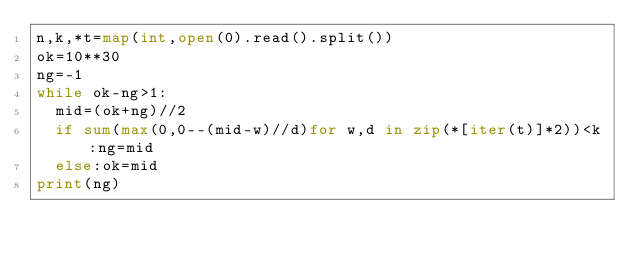Convert code to text. <code><loc_0><loc_0><loc_500><loc_500><_Python_>n,k,*t=map(int,open(0).read().split())
ok=10**30
ng=-1
while ok-ng>1:
  mid=(ok+ng)//2
  if sum(max(0,0--(mid-w)//d)for w,d in zip(*[iter(t)]*2))<k:ng=mid
  else:ok=mid
print(ng)</code> 